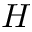Convert formula to latex. <formula><loc_0><loc_0><loc_500><loc_500>H</formula> 